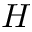Convert formula to latex. <formula><loc_0><loc_0><loc_500><loc_500>H</formula> 